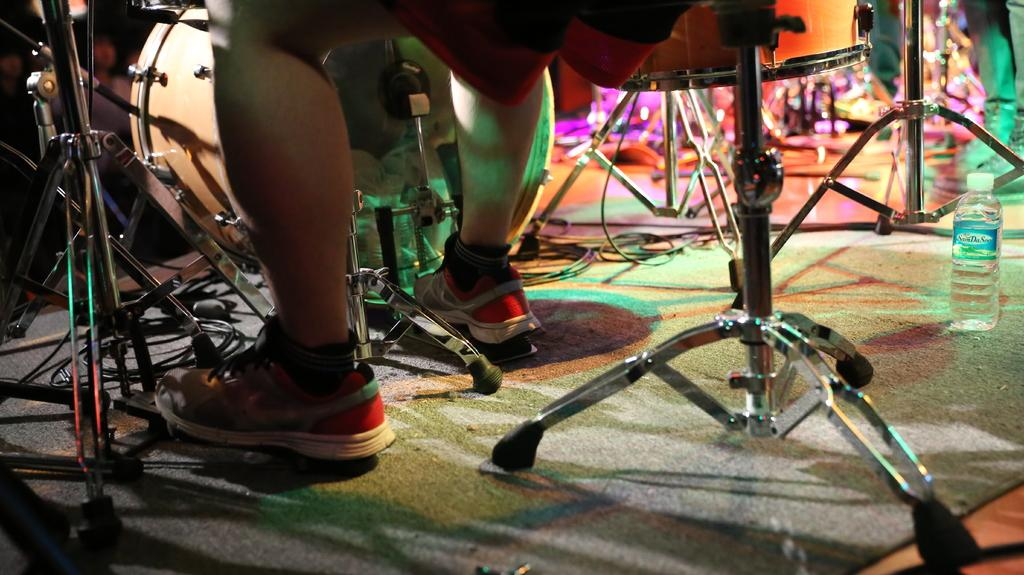What can be seen at the bottom of the image? There are legs of persons visible in the image. What is located in the background of the image? There are musical instruments in the background of the image. What object can be seen in the image besides the legs and musical instruments? There is a bottle in the image. What type of pancake is being played on the musical instruments in the image? There is no pancake present in the image, and musical instruments are not used to play pancakes. 